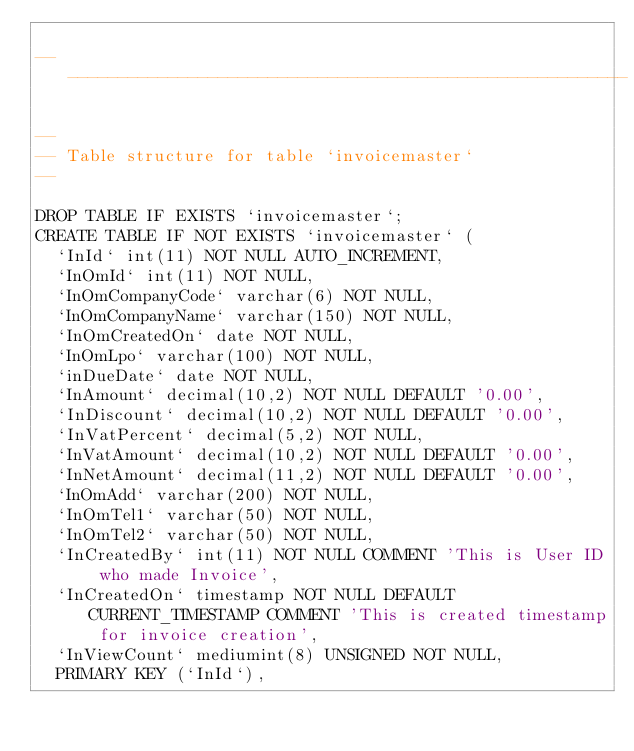Convert code to text. <code><loc_0><loc_0><loc_500><loc_500><_SQL_>
-- --------------------------------------------------------

--
-- Table structure for table `invoicemaster`
--

DROP TABLE IF EXISTS `invoicemaster`;
CREATE TABLE IF NOT EXISTS `invoicemaster` (
  `InId` int(11) NOT NULL AUTO_INCREMENT,
  `InOmId` int(11) NOT NULL,
  `InOmCompanyCode` varchar(6) NOT NULL,
  `InOmCompanyName` varchar(150) NOT NULL,
  `InOmCreatedOn` date NOT NULL,
  `InOmLpo` varchar(100) NOT NULL,
  `inDueDate` date NOT NULL,
  `InAmount` decimal(10,2) NOT NULL DEFAULT '0.00',
  `InDiscount` decimal(10,2) NOT NULL DEFAULT '0.00',
  `InVatPercent` decimal(5,2) NOT NULL,
  `InVatAmount` decimal(10,2) NOT NULL DEFAULT '0.00',
  `InNetAmount` decimal(11,2) NOT NULL DEFAULT '0.00',
  `InOmAdd` varchar(200) NOT NULL,
  `InOmTel1` varchar(50) NOT NULL,
  `InOmTel2` varchar(50) NOT NULL,
  `InCreatedBy` int(11) NOT NULL COMMENT 'This is User ID who made Invoice',
  `InCreatedOn` timestamp NOT NULL DEFAULT CURRENT_TIMESTAMP COMMENT 'This is created timestamp for invoice creation',
  `InViewCount` mediumint(8) UNSIGNED NOT NULL,
  PRIMARY KEY (`InId`),</code> 